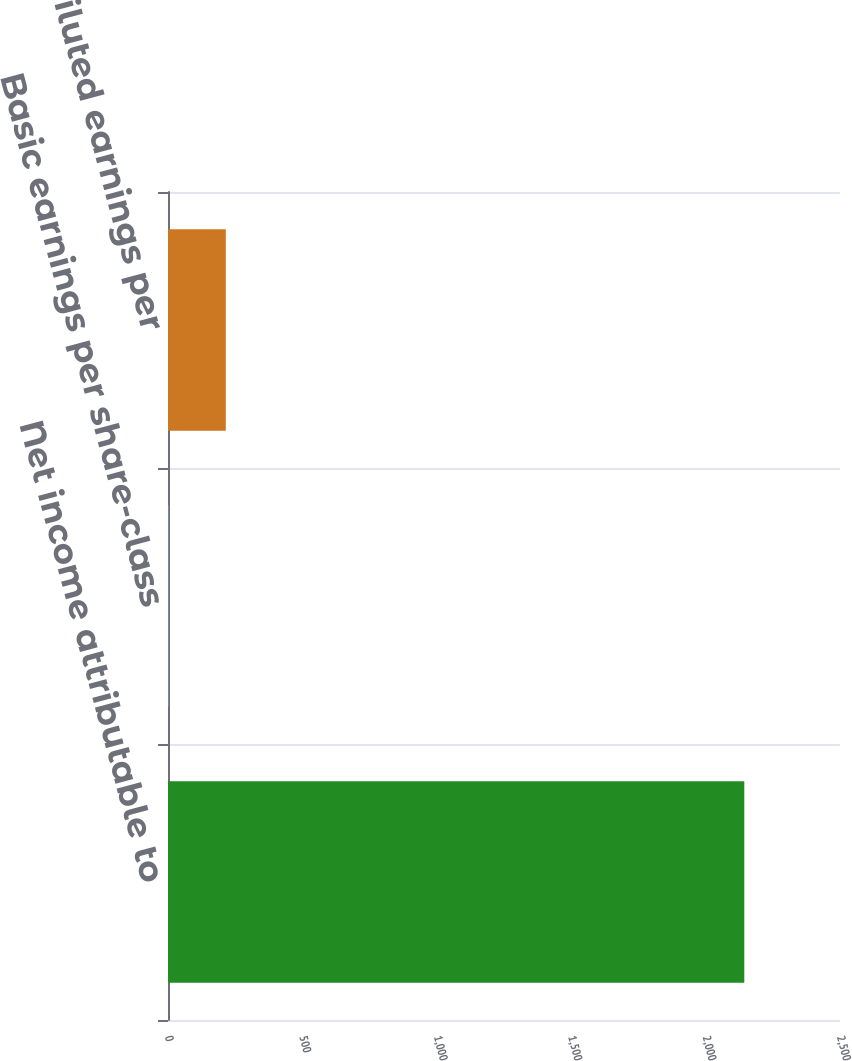Convert chart to OTSL. <chart><loc_0><loc_0><loc_500><loc_500><bar_chart><fcel>Net income attributable to<fcel>Basic earnings per share-class<fcel>Diluted earnings per<nl><fcel>2144<fcel>0.79<fcel>215.11<nl></chart> 